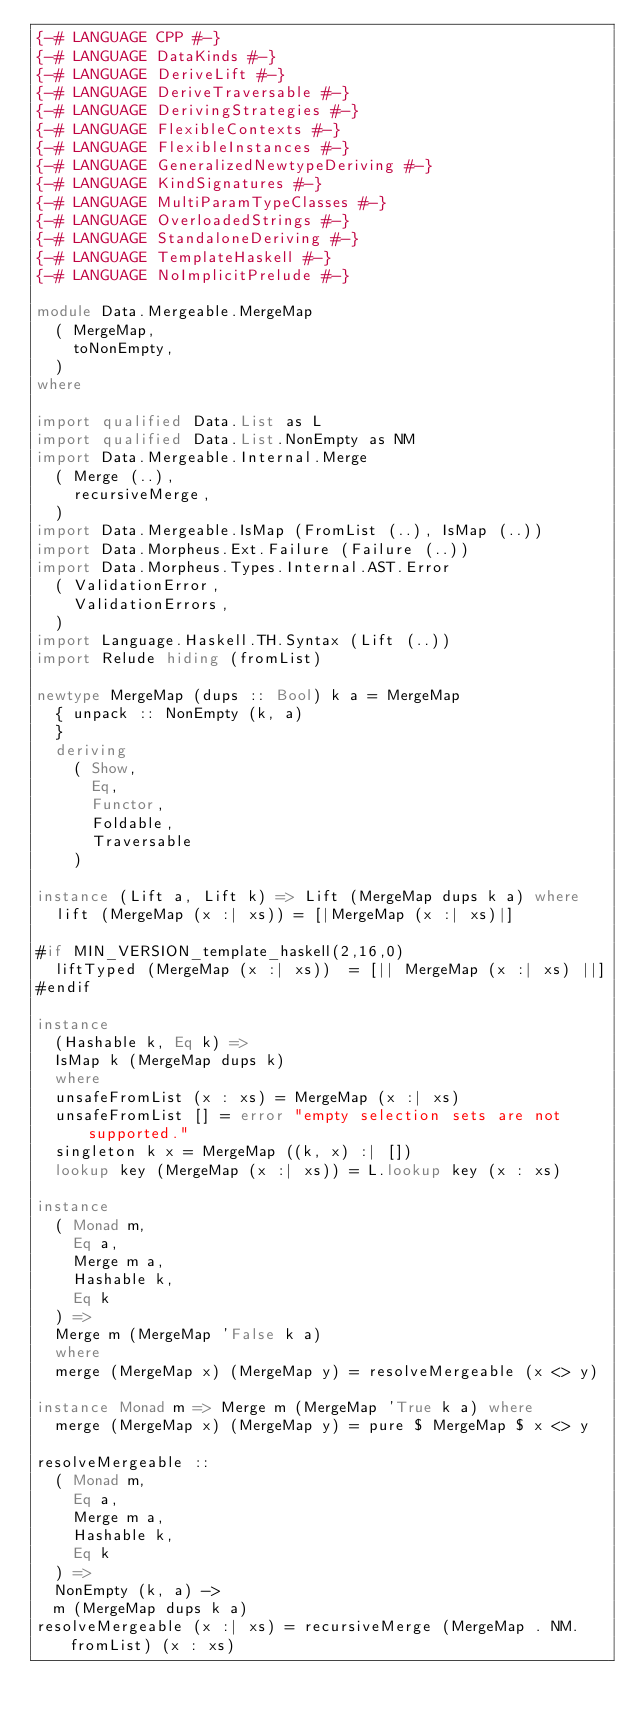Convert code to text. <code><loc_0><loc_0><loc_500><loc_500><_Haskell_>{-# LANGUAGE CPP #-}
{-# LANGUAGE DataKinds #-}
{-# LANGUAGE DeriveLift #-}
{-# LANGUAGE DeriveTraversable #-}
{-# LANGUAGE DerivingStrategies #-}
{-# LANGUAGE FlexibleContexts #-}
{-# LANGUAGE FlexibleInstances #-}
{-# LANGUAGE GeneralizedNewtypeDeriving #-}
{-# LANGUAGE KindSignatures #-}
{-# LANGUAGE MultiParamTypeClasses #-}
{-# LANGUAGE OverloadedStrings #-}
{-# LANGUAGE StandaloneDeriving #-}
{-# LANGUAGE TemplateHaskell #-}
{-# LANGUAGE NoImplicitPrelude #-}

module Data.Mergeable.MergeMap
  ( MergeMap,
    toNonEmpty,
  )
where

import qualified Data.List as L
import qualified Data.List.NonEmpty as NM
import Data.Mergeable.Internal.Merge
  ( Merge (..),
    recursiveMerge,
  )
import Data.Mergeable.IsMap (FromList (..), IsMap (..))
import Data.Morpheus.Ext.Failure (Failure (..))
import Data.Morpheus.Types.Internal.AST.Error
  ( ValidationError,
    ValidationErrors,
  )
import Language.Haskell.TH.Syntax (Lift (..))
import Relude hiding (fromList)

newtype MergeMap (dups :: Bool) k a = MergeMap
  { unpack :: NonEmpty (k, a)
  }
  deriving
    ( Show,
      Eq,
      Functor,
      Foldable,
      Traversable
    )

instance (Lift a, Lift k) => Lift (MergeMap dups k a) where
  lift (MergeMap (x :| xs)) = [|MergeMap (x :| xs)|]

#if MIN_VERSION_template_haskell(2,16,0)
  liftTyped (MergeMap (x :| xs))  = [|| MergeMap (x :| xs) ||]
#endif

instance
  (Hashable k, Eq k) =>
  IsMap k (MergeMap dups k)
  where
  unsafeFromList (x : xs) = MergeMap (x :| xs)
  unsafeFromList [] = error "empty selection sets are not supported."
  singleton k x = MergeMap ((k, x) :| [])
  lookup key (MergeMap (x :| xs)) = L.lookup key (x : xs)

instance
  ( Monad m,
    Eq a,
    Merge m a,
    Hashable k,
    Eq k
  ) =>
  Merge m (MergeMap 'False k a)
  where
  merge (MergeMap x) (MergeMap y) = resolveMergeable (x <> y)

instance Monad m => Merge m (MergeMap 'True k a) where
  merge (MergeMap x) (MergeMap y) = pure $ MergeMap $ x <> y

resolveMergeable ::
  ( Monad m,
    Eq a,
    Merge m a,
    Hashable k,
    Eq k
  ) =>
  NonEmpty (k, a) ->
  m (MergeMap dups k a)
resolveMergeable (x :| xs) = recursiveMerge (MergeMap . NM.fromList) (x : xs)
</code> 